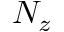<formula> <loc_0><loc_0><loc_500><loc_500>N _ { z }</formula> 